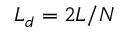Convert formula to latex. <formula><loc_0><loc_0><loc_500><loc_500>L _ { d } = 2 L / N</formula> 